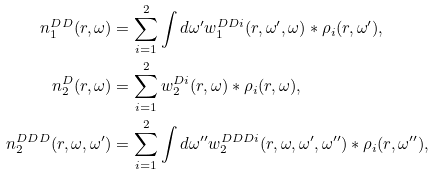<formula> <loc_0><loc_0><loc_500><loc_500>n _ { 1 } ^ { D D } ( r , \omega ) & = \sum _ { i = 1 } ^ { 2 } \int d \omega ^ { \prime } w _ { 1 } ^ { D D i } ( r , \omega ^ { \prime } , \omega ) * \rho _ { i } ( r , \omega ^ { \prime } ) , \\ n _ { 2 } ^ { D } ( r , \omega ) & = \sum _ { i = 1 } ^ { 2 } w _ { 2 } ^ { D i } ( r , \omega ) * \rho _ { i } ( r , \omega ) , \\ n _ { 2 } ^ { D D D } ( r , \omega , \omega ^ { \prime } ) & = \sum _ { i = 1 } ^ { 2 } \int d \omega ^ { \prime \prime } w _ { 2 } ^ { D D D i } ( r , \omega , \omega ^ { \prime } , \omega ^ { \prime \prime } ) * \rho _ { i } ( r , \omega ^ { \prime \prime } ) ,</formula> 